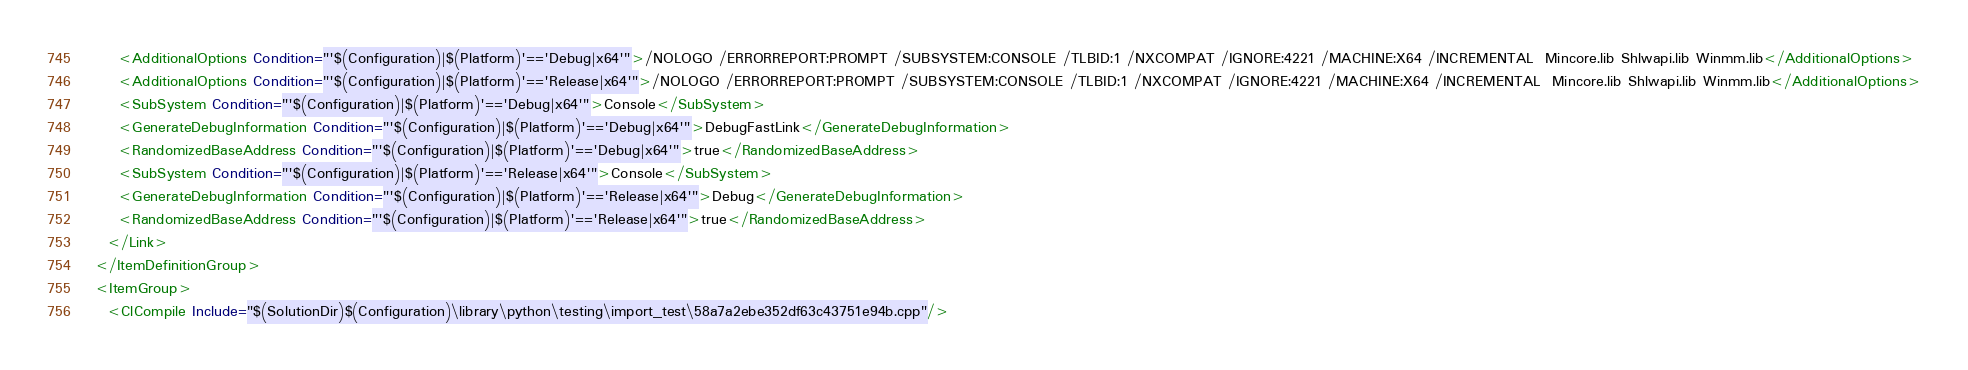<code> <loc_0><loc_0><loc_500><loc_500><_XML_>      <AdditionalOptions Condition="'$(Configuration)|$(Platform)'=='Debug|x64'">/NOLOGO /ERRORREPORT:PROMPT /SUBSYSTEM:CONSOLE /TLBID:1 /NXCOMPAT /IGNORE:4221 /MACHINE:X64 /INCREMENTAL  Mincore.lib Shlwapi.lib Winmm.lib</AdditionalOptions>
      <AdditionalOptions Condition="'$(Configuration)|$(Platform)'=='Release|x64'">/NOLOGO /ERRORREPORT:PROMPT /SUBSYSTEM:CONSOLE /TLBID:1 /NXCOMPAT /IGNORE:4221 /MACHINE:X64 /INCREMENTAL  Mincore.lib Shlwapi.lib Winmm.lib</AdditionalOptions>
      <SubSystem Condition="'$(Configuration)|$(Platform)'=='Debug|x64'">Console</SubSystem>
      <GenerateDebugInformation Condition="'$(Configuration)|$(Platform)'=='Debug|x64'">DebugFastLink</GenerateDebugInformation>
      <RandomizedBaseAddress Condition="'$(Configuration)|$(Platform)'=='Debug|x64'">true</RandomizedBaseAddress>
      <SubSystem Condition="'$(Configuration)|$(Platform)'=='Release|x64'">Console</SubSystem>
      <GenerateDebugInformation Condition="'$(Configuration)|$(Platform)'=='Release|x64'">Debug</GenerateDebugInformation>
      <RandomizedBaseAddress Condition="'$(Configuration)|$(Platform)'=='Release|x64'">true</RandomizedBaseAddress>
    </Link>
  </ItemDefinitionGroup>
  <ItemGroup>
    <ClCompile Include="$(SolutionDir)$(Configuration)\library\python\testing\import_test\58a7a2ebe352df63c43751e94b.cpp"/></code> 